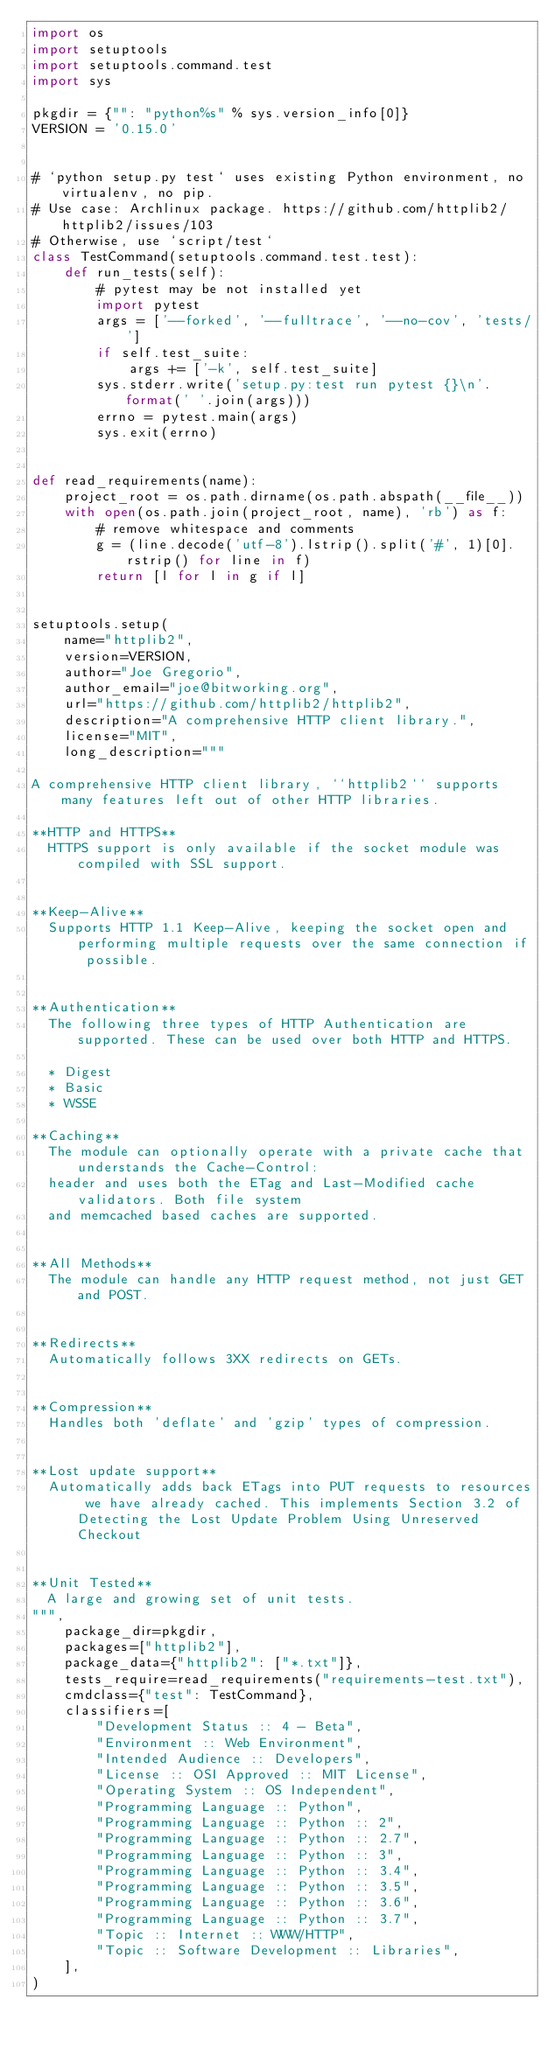Convert code to text. <code><loc_0><loc_0><loc_500><loc_500><_Python_>import os
import setuptools
import setuptools.command.test
import sys

pkgdir = {"": "python%s" % sys.version_info[0]}
VERSION = '0.15.0'


# `python setup.py test` uses existing Python environment, no virtualenv, no pip.
# Use case: Archlinux package. https://github.com/httplib2/httplib2/issues/103
# Otherwise, use `script/test`
class TestCommand(setuptools.command.test.test):
    def run_tests(self):
        # pytest may be not installed yet
        import pytest
        args = ['--forked', '--fulltrace', '--no-cov', 'tests/']
        if self.test_suite:
            args += ['-k', self.test_suite]
        sys.stderr.write('setup.py:test run pytest {}\n'.format(' '.join(args)))
        errno = pytest.main(args)
        sys.exit(errno)


def read_requirements(name):
    project_root = os.path.dirname(os.path.abspath(__file__))
    with open(os.path.join(project_root, name), 'rb') as f:
        # remove whitespace and comments
        g = (line.decode('utf-8').lstrip().split('#', 1)[0].rstrip() for line in f)
        return [l for l in g if l]


setuptools.setup(
    name="httplib2",
    version=VERSION,
    author="Joe Gregorio",
    author_email="joe@bitworking.org",
    url="https://github.com/httplib2/httplib2",
    description="A comprehensive HTTP client library.",
    license="MIT",
    long_description="""

A comprehensive HTTP client library, ``httplib2`` supports many features left out of other HTTP libraries.

**HTTP and HTTPS**
  HTTPS support is only available if the socket module was compiled with SSL support.


**Keep-Alive**
  Supports HTTP 1.1 Keep-Alive, keeping the socket open and performing multiple requests over the same connection if possible.


**Authentication**
  The following three types of HTTP Authentication are supported. These can be used over both HTTP and HTTPS.

  * Digest
  * Basic
  * WSSE

**Caching**
  The module can optionally operate with a private cache that understands the Cache-Control:
  header and uses both the ETag and Last-Modified cache validators. Both file system
  and memcached based caches are supported.


**All Methods**
  The module can handle any HTTP request method, not just GET and POST.


**Redirects**
  Automatically follows 3XX redirects on GETs.


**Compression**
  Handles both 'deflate' and 'gzip' types of compression.


**Lost update support**
  Automatically adds back ETags into PUT requests to resources we have already cached. This implements Section 3.2 of Detecting the Lost Update Problem Using Unreserved Checkout


**Unit Tested**
  A large and growing set of unit tests.
""",
    package_dir=pkgdir,
    packages=["httplib2"],
    package_data={"httplib2": ["*.txt"]},
    tests_require=read_requirements("requirements-test.txt"),
    cmdclass={"test": TestCommand},
    classifiers=[
        "Development Status :: 4 - Beta",
        "Environment :: Web Environment",
        "Intended Audience :: Developers",
        "License :: OSI Approved :: MIT License",
        "Operating System :: OS Independent",
        "Programming Language :: Python",
        "Programming Language :: Python :: 2",
        "Programming Language :: Python :: 2.7",
        "Programming Language :: Python :: 3",
        "Programming Language :: Python :: 3.4",
        "Programming Language :: Python :: 3.5",
        "Programming Language :: Python :: 3.6",
        "Programming Language :: Python :: 3.7",
        "Topic :: Internet :: WWW/HTTP",
        "Topic :: Software Development :: Libraries",
    ],
)
</code> 